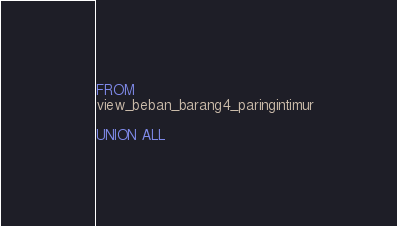<code> <loc_0><loc_0><loc_500><loc_500><_SQL_>FROM
view_beban_barang4_paringintimur

UNION ALL
</code> 